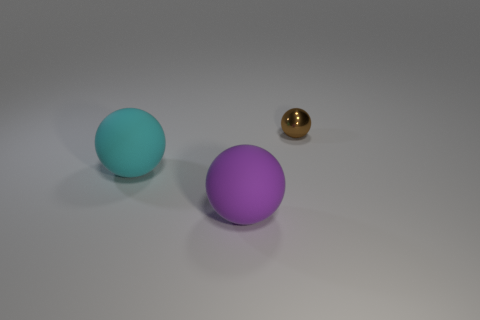Is there any other thing that is the same size as the brown thing?
Ensure brevity in your answer.  No. Are there any other things that have the same material as the brown thing?
Provide a succinct answer. No. How many other objects are there of the same shape as the cyan rubber object?
Provide a short and direct response. 2. How many other objects are there of the same size as the brown thing?
Keep it short and to the point. 0. Are the cyan object and the purple thing made of the same material?
Ensure brevity in your answer.  Yes. What color is the tiny metal thing that is behind the rubber ball that is in front of the cyan thing?
Keep it short and to the point. Brown. The brown thing that is the same shape as the large purple matte object is what size?
Keep it short and to the point. Small. What number of matte balls are in front of the tiny brown ball behind the large cyan rubber sphere left of the large purple matte thing?
Offer a very short reply. 2. Are there more balls than purple metal cubes?
Provide a short and direct response. Yes. How many large green objects are there?
Your answer should be very brief. 0. 